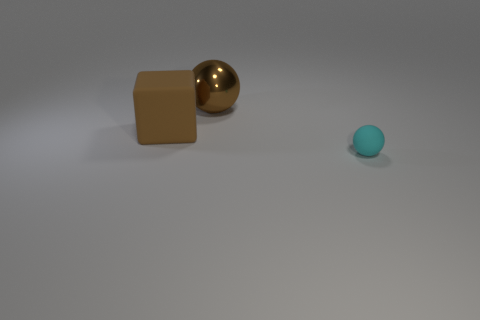Add 3 tiny cyan matte cylinders. How many objects exist? 6 Subtract all blocks. How many objects are left? 2 Subtract 1 cyan spheres. How many objects are left? 2 Subtract all purple cubes. Subtract all blue spheres. How many cubes are left? 1 Subtract all red cylinders. Subtract all matte objects. How many objects are left? 1 Add 2 cyan matte objects. How many cyan matte objects are left? 3 Add 2 brown blocks. How many brown blocks exist? 3 